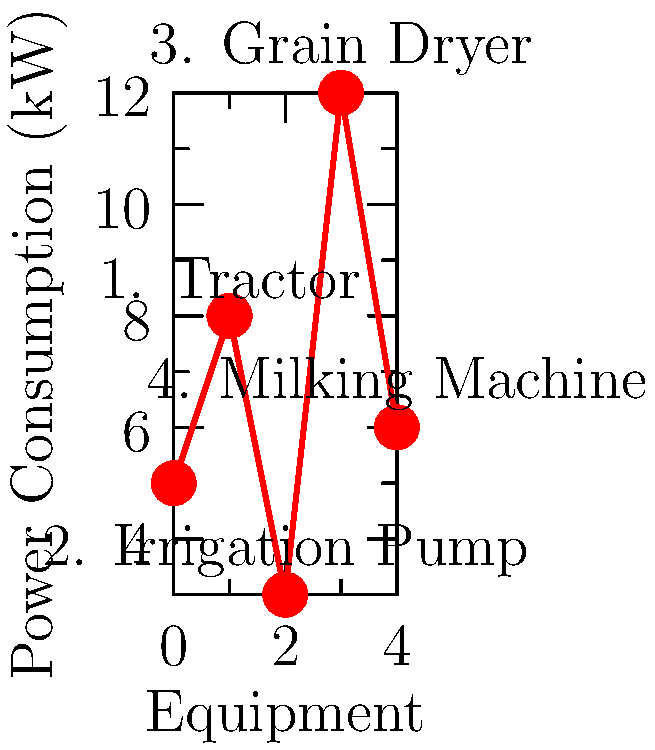As a farmer looking to optimize energy usage, you're analyzing the power consumption of various farm equipment. Based on the chart, which piece of equipment consumes the most power and how much more does it consume compared to the irrigation pump? To answer this question, we need to follow these steps:

1. Identify the equipment with the highest power consumption:
   - Tractor: 8 kW
   - Irrigation Pump: 3 kW
   - Grain Dryer: 12 kW
   - Milking Machine: 6 kW

   The grain dryer has the highest power consumption at 12 kW.

2. Calculate the difference in power consumption between the grain dryer and the irrigation pump:
   $\text{Difference} = \text{Grain Dryer} - \text{Irrigation Pump}$
   $\text{Difference} = 12 \text{ kW} - 3 \text{ kW} = 9 \text{ kW}$

Therefore, the grain dryer consumes 9 kW more power than the irrigation pump.
Answer: Grain dryer; 9 kW more 